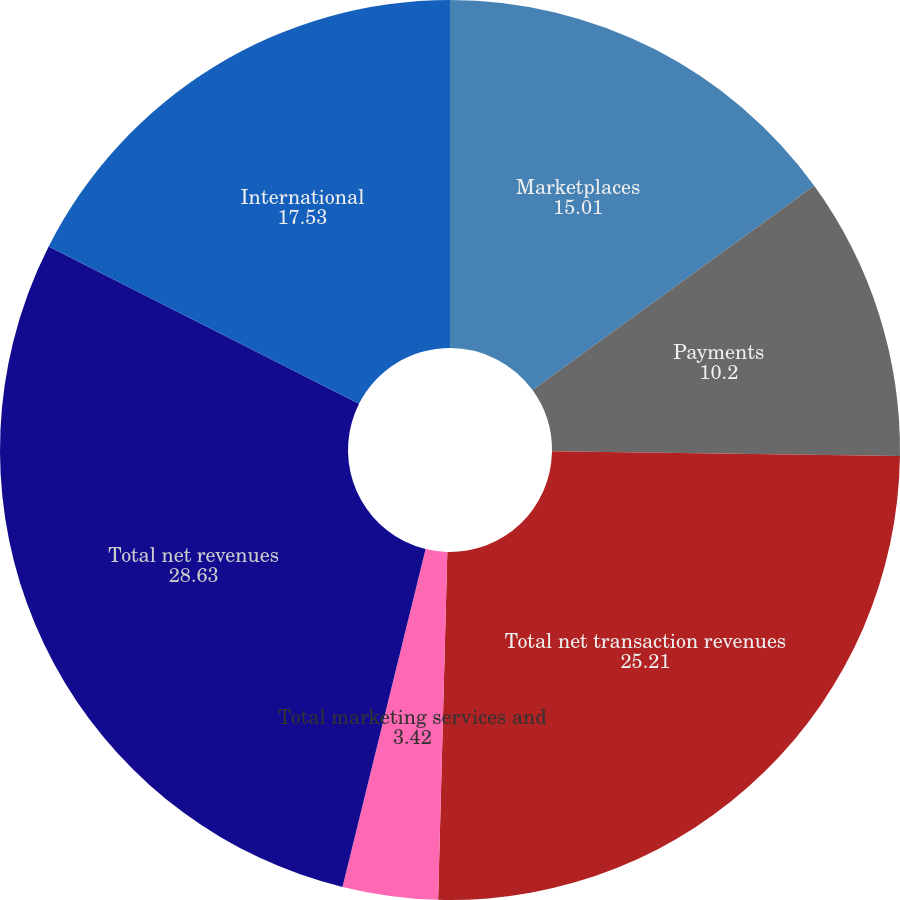Convert chart. <chart><loc_0><loc_0><loc_500><loc_500><pie_chart><fcel>Marketplaces<fcel>Payments<fcel>Total net transaction revenues<fcel>Total marketing services and<fcel>Total net revenues<fcel>International<nl><fcel>15.01%<fcel>10.2%<fcel>25.21%<fcel>3.42%<fcel>28.63%<fcel>17.53%<nl></chart> 